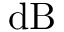<formula> <loc_0><loc_0><loc_500><loc_500>d B</formula> 